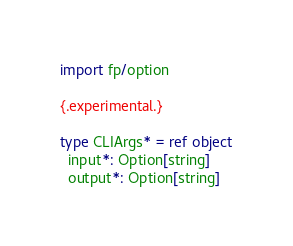<code> <loc_0><loc_0><loc_500><loc_500><_Nim_>import fp/option

{.experimental.}

type CLIArgs* = ref object
  input*: Option[string]
  output*: Option[string]
</code> 